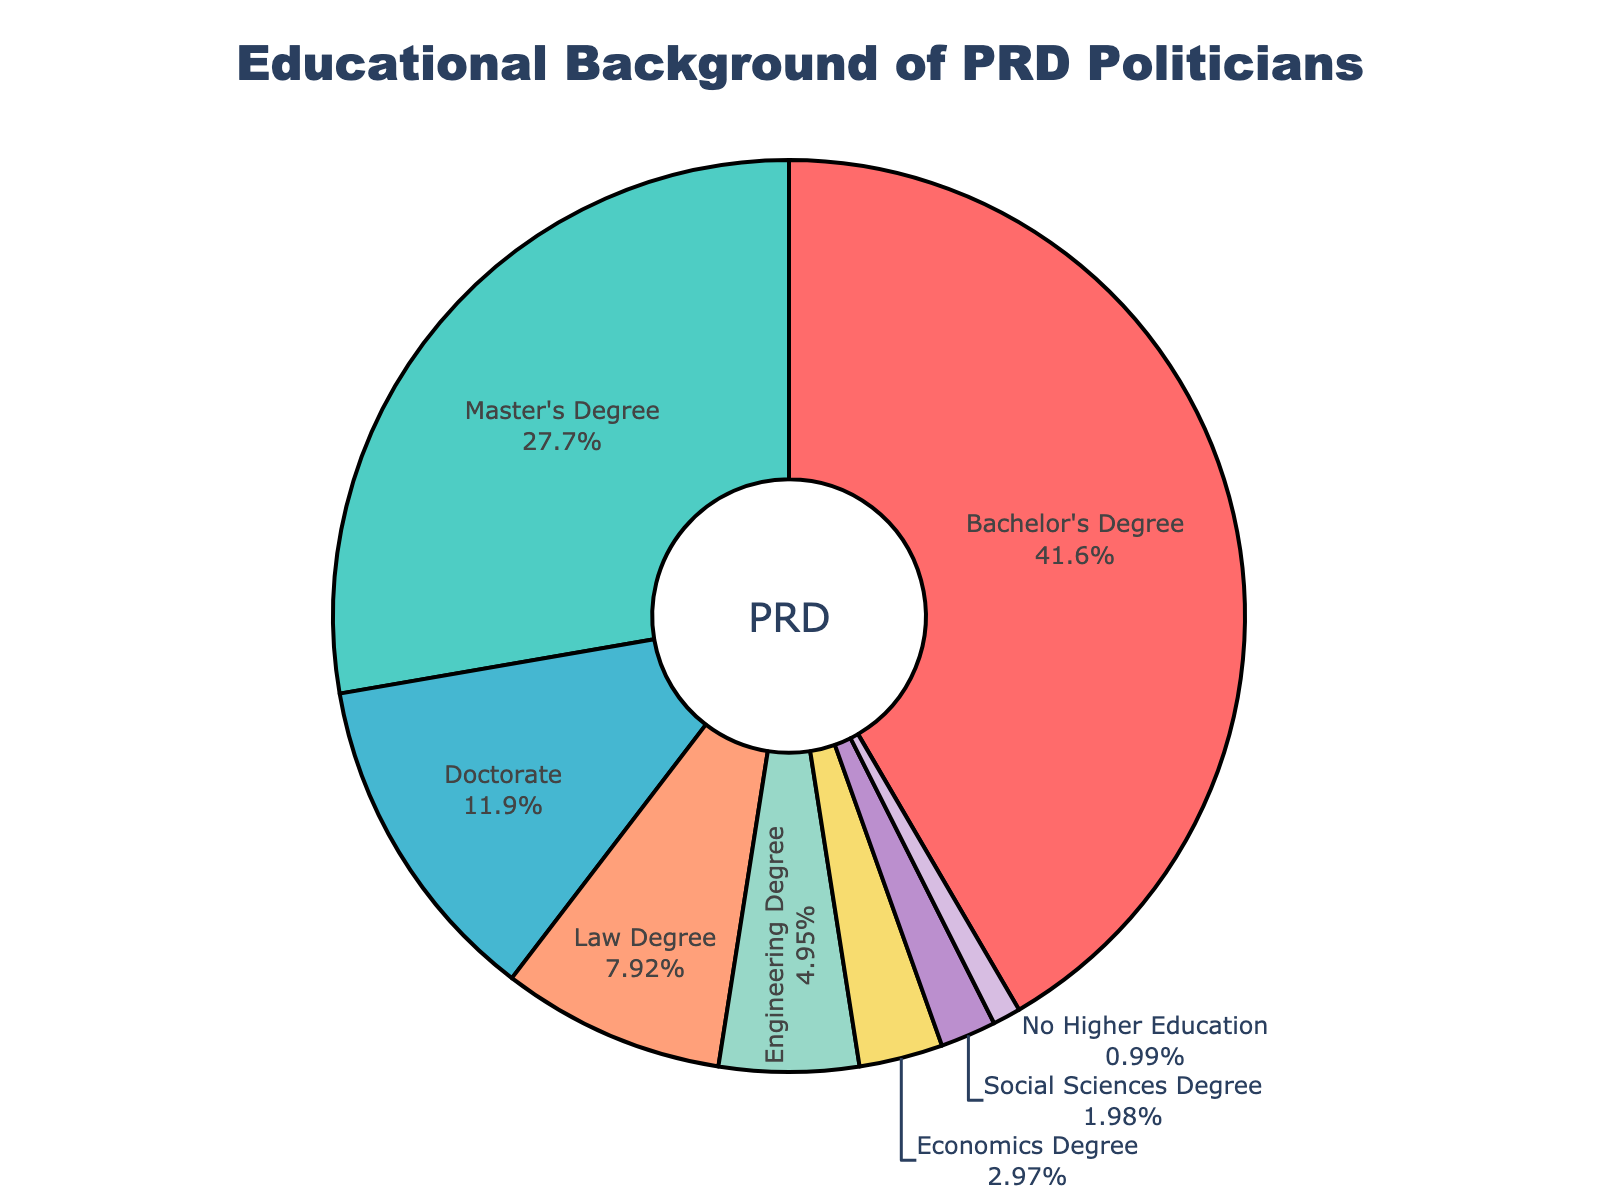What educational background has the largest proportion of PRD politicians? The pie chart shows the percentages of different educational backgrounds among PRD politicians. The largest section of the chart is labeled "Bachelor's Degree" with 42%.
Answer: Bachelor's Degree What is the combined percentage of PRD politicians with a Master's Degree and a Doctorate? According to the chart, the percentage of PRD politicians with a Master's Degree is 28% and with a Doctorate is 12%. By adding these percentages together: 28% + 12% = 40%.
Answer: 40% How does the proportion of PRD politicians with a Law Degree compare to those with a Social Sciences Degree? The pie chart shows that 8% of PRD politicians have a Law Degree, whereas 2% have a Social Sciences Degree. By comparing these, 8% is greater than 2%.
Answer: Law Degree is greater What is the percentage difference between PRD politicians with an Engineering Degree and those with an Economics Degree? The pie chart shows that 5% of PRD politicians have an Engineering Degree and 3% have an Economics Degree. The difference between these percentages is: 5% - 3% = 2%.
Answer: 2% Is the percentage of PRD politicians with no higher education greater or less than those with Social Sciences degrees? The pie chart shows that 1% of PRD politicians have no higher education and 2% have a Social Sciences Degree. Since 1% is less than 2%, no higher education is less.
Answer: Less What is the total percentage of PRD politicians with Bachelor's, Master's, or Doctorate degrees? According to the pie chart, 42% have a Bachelor's Degree, 28% have a Master's Degree, and 12% have a Doctorate. Adding these together gives: 42% + 28% + 12% = 82%.
Answer: 82% Which educational background has a smaller proportion of PRD politicians, Economics Degree or No Higher Education? The pie chart shows that 3% of PRD politicians have an Economics Degree and 1% have no higher education. 1% is smaller than 3%.
Answer: No Higher Education How many percent of PRD politicians have educational backgrounds other than Law and Engineering degrees? The pie chart shows the proportions for each category. Adding the percentages of Law (8%) and Engineering (5%) gives 13%. The percentage of other educational backgrounds is 100% - 13% = 87%.
Answer: 87% 